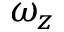Convert formula to latex. <formula><loc_0><loc_0><loc_500><loc_500>\omega _ { z }</formula> 